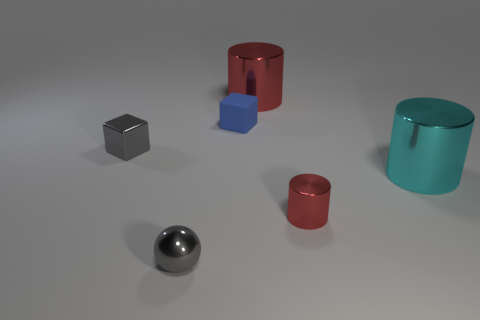Are there any other things that have the same material as the small blue cube?
Provide a short and direct response. No. What is the material of the cube that is the same color as the sphere?
Give a very brief answer. Metal. Do the tiny shiny object to the right of the big red cylinder and the large metal cylinder that is on the left side of the large cyan thing have the same color?
Your response must be concise. Yes. Is there a red cylinder that has the same size as the rubber object?
Give a very brief answer. Yes. How many tiny purple cylinders are there?
Your answer should be very brief. 0. What number of big shiny objects are in front of the tiny rubber block?
Offer a terse response. 1. Is the tiny gray sphere made of the same material as the tiny blue thing?
Make the answer very short. No. What number of objects are behind the small blue block and left of the matte cube?
Offer a very short reply. 0. What number of other things are the same color as the tiny matte object?
Your answer should be compact. 0. How many blue things are either small rubber cubes or metallic cylinders?
Offer a very short reply. 1. 